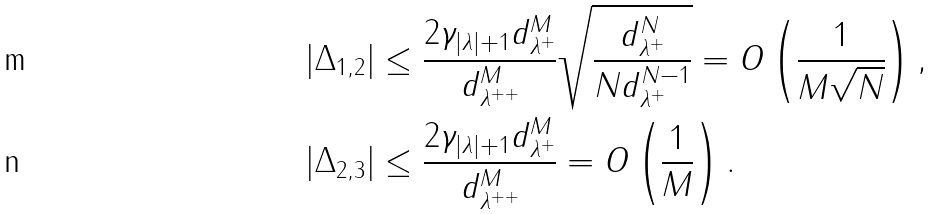Convert formula to latex. <formula><loc_0><loc_0><loc_500><loc_500>| \Delta _ { 1 , 2 } | & \leq \frac { 2 \gamma _ { | \lambda | + 1 } d _ { \lambda ^ { + } } ^ { M } } { d _ { \lambda ^ { + + } } ^ { M } } \sqrt { \frac { d _ { \lambda ^ { + } } ^ { N } } { N d _ { \lambda ^ { + } } ^ { N - 1 } } } = O \left ( \frac { 1 } { M \sqrt { N } } \right ) , \\ | \Delta _ { 2 , 3 } | & \leq \frac { 2 \gamma _ { | \lambda | + 1 } d _ { \lambda ^ { + } } ^ { M } } { d _ { \lambda ^ { + + } } ^ { M } } = O \left ( \frac { 1 } { M } \right ) .</formula> 